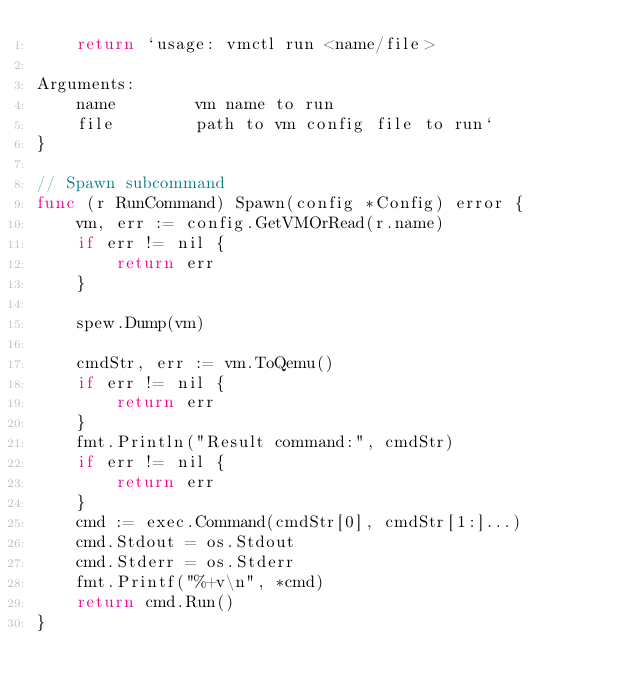<code> <loc_0><loc_0><loc_500><loc_500><_Go_>	return `usage: vmctl run <name/file>

Arguments:	
	name		vm name to run
	file		path to vm config file to run`
}

// Spawn subcommand
func (r RunCommand) Spawn(config *Config) error {
	vm, err := config.GetVMOrRead(r.name)
	if err != nil {
		return err
	}

	spew.Dump(vm)

	cmdStr, err := vm.ToQemu()
	if err != nil {
		return err
	}
	fmt.Println("Result command:", cmdStr)
	if err != nil {
		return err
	}
	cmd := exec.Command(cmdStr[0], cmdStr[1:]...)
	cmd.Stdout = os.Stdout
	cmd.Stderr = os.Stderr
	fmt.Printf("%+v\n", *cmd)
	return cmd.Run()
}
</code> 